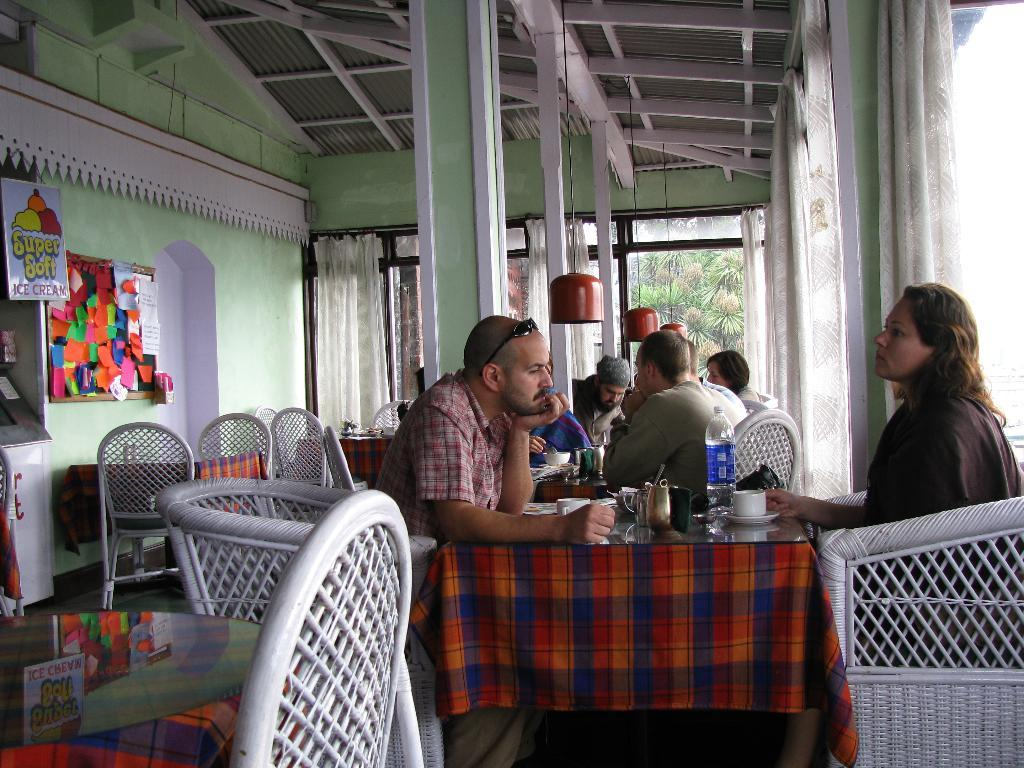What type of establishment are the people in? The people are in a restaurant. Where are the people seated in the restaurant? The people are sitting at a table. What can be seen on the table where the people are sitting? There is a cup and a water bottle on the table. What is the color of the walls in the restaurant? The walls are green in color. What type of rod is being used to measure the distance between the people in the image? There is no rod or measuring device present in the image. What kind of bait is on the table next to the cup and water bottle? There is no bait present in the image; only a cup and a water bottle are visible on the table. 